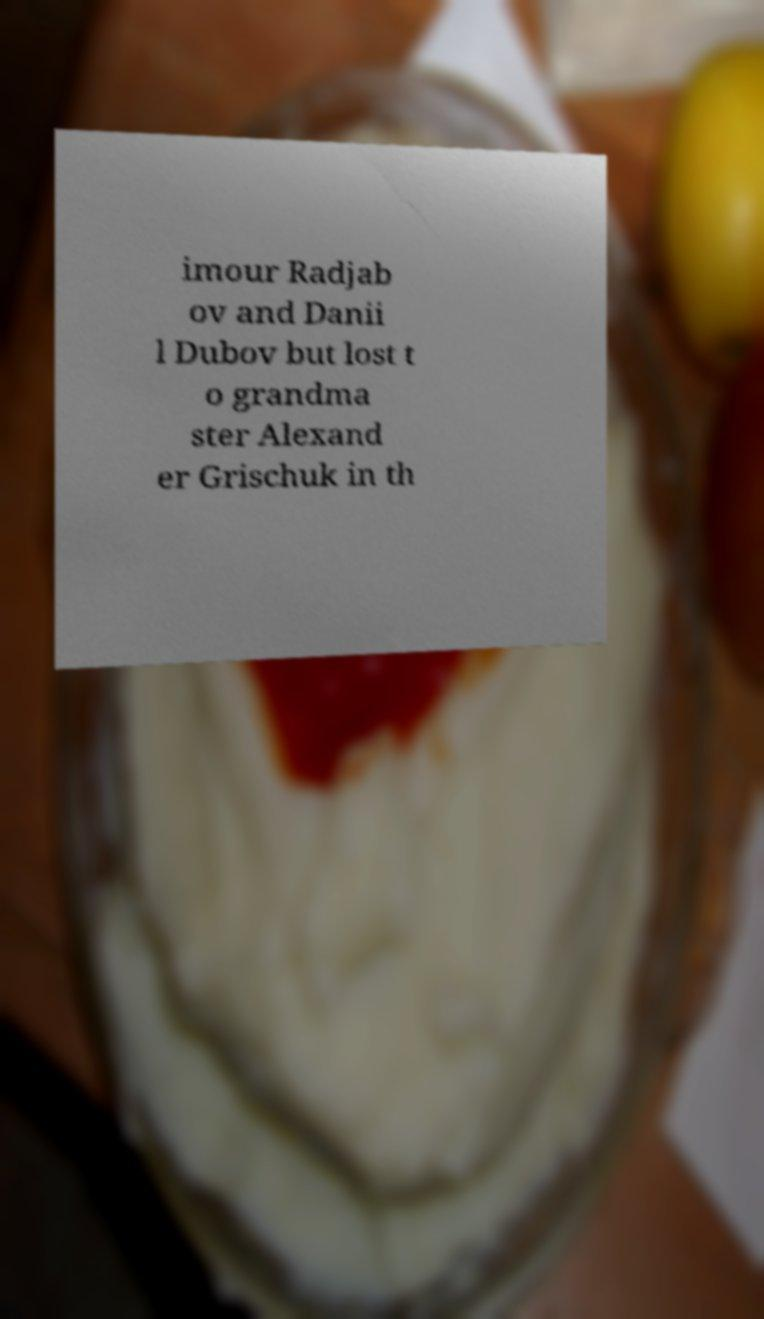Could you assist in decoding the text presented in this image and type it out clearly? imour Radjab ov and Danii l Dubov but lost t o grandma ster Alexand er Grischuk in th 